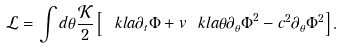Convert formula to latex. <formula><loc_0><loc_0><loc_500><loc_500>\mathcal { L } = \int d \theta \frac { \mathcal { K } } { 2 } \left [ \ k l a { \partial _ { t } \Phi + v \ k l a { \theta } \partial _ { \theta } \Phi } ^ { 2 } - c ^ { 2 } \partial _ { \theta } \Phi ^ { 2 } \right ] .</formula> 